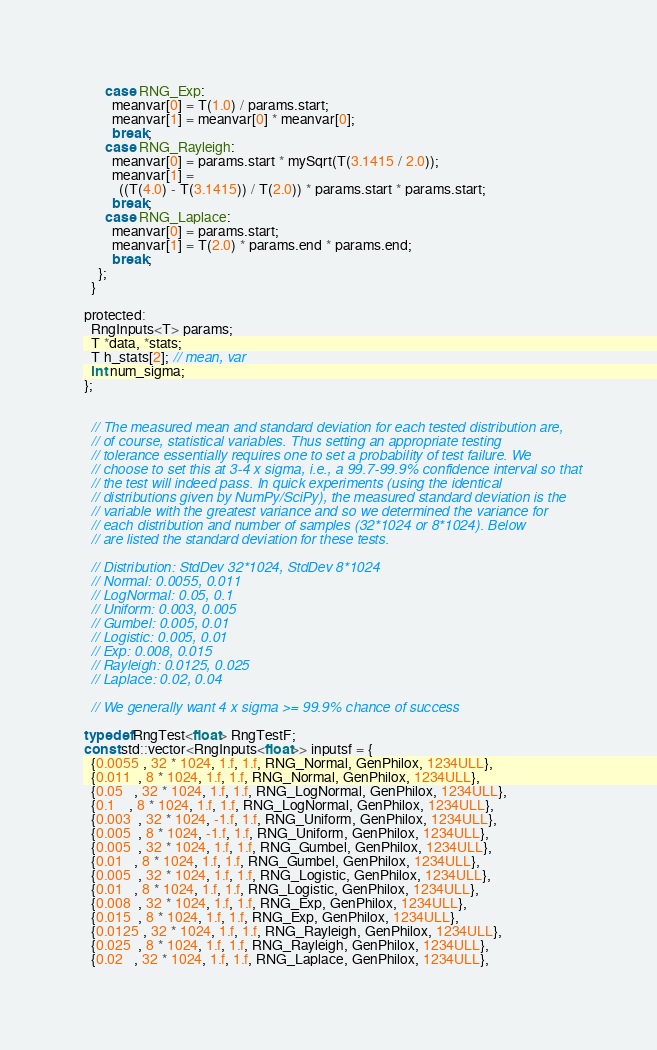Convert code to text. <code><loc_0><loc_0><loc_500><loc_500><_Cuda_>      case RNG_Exp:
        meanvar[0] = T(1.0) / params.start;
        meanvar[1] = meanvar[0] * meanvar[0];
        break;
      case RNG_Rayleigh:
        meanvar[0] = params.start * mySqrt(T(3.1415 / 2.0));
        meanvar[1] =
          ((T(4.0) - T(3.1415)) / T(2.0)) * params.start * params.start;
        break;
      case RNG_Laplace:
        meanvar[0] = params.start;
        meanvar[1] = T(2.0) * params.end * params.end;
        break;
    };
  }

protected:
  RngInputs<T> params;
  T *data, *stats;
  T h_stats[2]; // mean, var
  int num_sigma;
};


  // The measured mean and standard deviation for each tested distribution are,
  // of course, statistical variables. Thus setting an appropriate testing
  // tolerance essentially requires one to set a probability of test failure. We
  // choose to set this at 3-4 x sigma, i.e., a 99.7-99.9% confidence interval so that
  // the test will indeed pass. In quick experiments (using the identical
  // distributions given by NumPy/SciPy), the measured standard deviation is the
  // variable with the greatest variance and so we determined the variance for
  // each distribution and number of samples (32*1024 or 8*1024). Below
  // are listed the standard deviation for these tests.

  // Distribution: StdDev 32*1024, StdDev 8*1024
  // Normal: 0.0055, 0.011
  // LogNormal: 0.05, 0.1
  // Uniform: 0.003, 0.005
  // Gumbel: 0.005, 0.01
  // Logistic: 0.005, 0.01
  // Exp: 0.008, 0.015
  // Rayleigh: 0.0125, 0.025
  // Laplace: 0.02, 0.04

  // We generally want 4 x sigma >= 99.9% chance of success

typedef RngTest<float> RngTestF;
const std::vector<RngInputs<float>> inputsf = {
  {0.0055 , 32 * 1024, 1.f, 1.f, RNG_Normal, GenPhilox, 1234ULL}, 
  {0.011  , 8 * 1024, 1.f, 1.f, RNG_Normal, GenPhilox, 1234ULL},
  {0.05   , 32 * 1024, 1.f, 1.f, RNG_LogNormal, GenPhilox, 1234ULL},
  {0.1    , 8 * 1024, 1.f, 1.f, RNG_LogNormal, GenPhilox, 1234ULL},
  {0.003  , 32 * 1024, -1.f, 1.f, RNG_Uniform, GenPhilox, 1234ULL},
  {0.005  , 8 * 1024, -1.f, 1.f, RNG_Uniform, GenPhilox, 1234ULL},
  {0.005  , 32 * 1024, 1.f, 1.f, RNG_Gumbel, GenPhilox, 1234ULL},
  {0.01   , 8 * 1024, 1.f, 1.f, RNG_Gumbel, GenPhilox, 1234ULL},
  {0.005  , 32 * 1024, 1.f, 1.f, RNG_Logistic, GenPhilox, 1234ULL},
  {0.01   , 8 * 1024, 1.f, 1.f, RNG_Logistic, GenPhilox, 1234ULL},
  {0.008  , 32 * 1024, 1.f, 1.f, RNG_Exp, GenPhilox, 1234ULL},
  {0.015  , 8 * 1024, 1.f, 1.f, RNG_Exp, GenPhilox, 1234ULL},
  {0.0125 , 32 * 1024, 1.f, 1.f, RNG_Rayleigh, GenPhilox, 1234ULL},
  {0.025  , 8 * 1024, 1.f, 1.f, RNG_Rayleigh, GenPhilox, 1234ULL},
  {0.02   , 32 * 1024, 1.f, 1.f, RNG_Laplace, GenPhilox, 1234ULL},</code> 